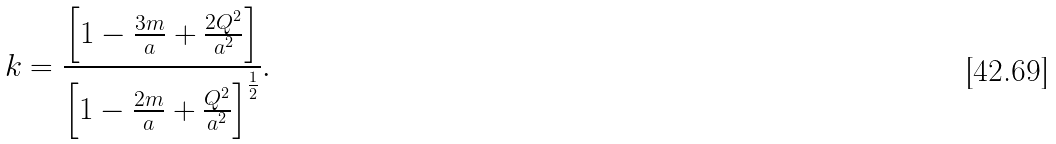Convert formula to latex. <formula><loc_0><loc_0><loc_500><loc_500>k = \frac { \left [ 1 - \frac { 3 m } { a } + \frac { 2 Q ^ { 2 } } { a ^ { 2 } } \right ] } { \left [ 1 - \frac { 2 m } { a } + \frac { Q ^ { 2 } } { a ^ { 2 } } \right ] ^ { \frac { 1 } { 2 } } } .</formula> 